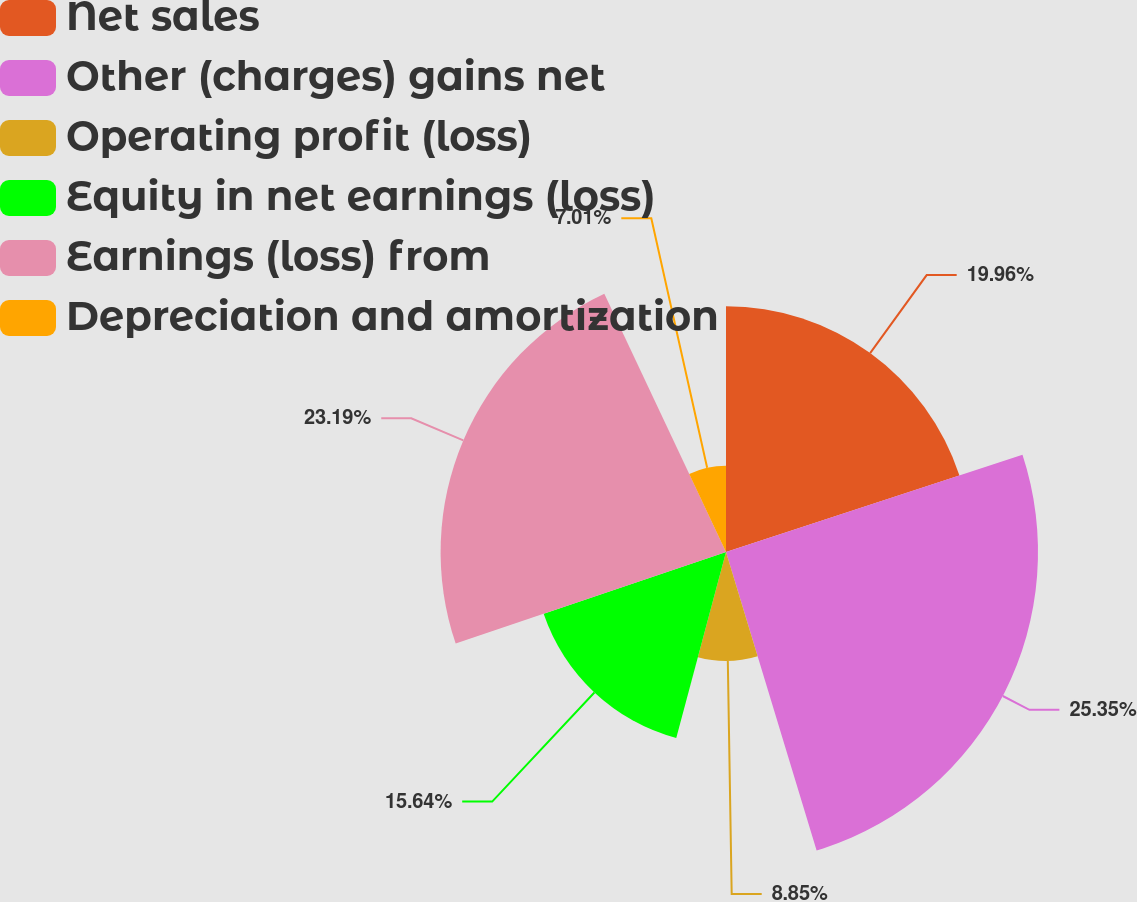<chart> <loc_0><loc_0><loc_500><loc_500><pie_chart><fcel>Net sales<fcel>Other (charges) gains net<fcel>Operating profit (loss)<fcel>Equity in net earnings (loss)<fcel>Earnings (loss) from<fcel>Depreciation and amortization<nl><fcel>19.96%<fcel>25.35%<fcel>8.85%<fcel>15.64%<fcel>23.19%<fcel>7.01%<nl></chart> 